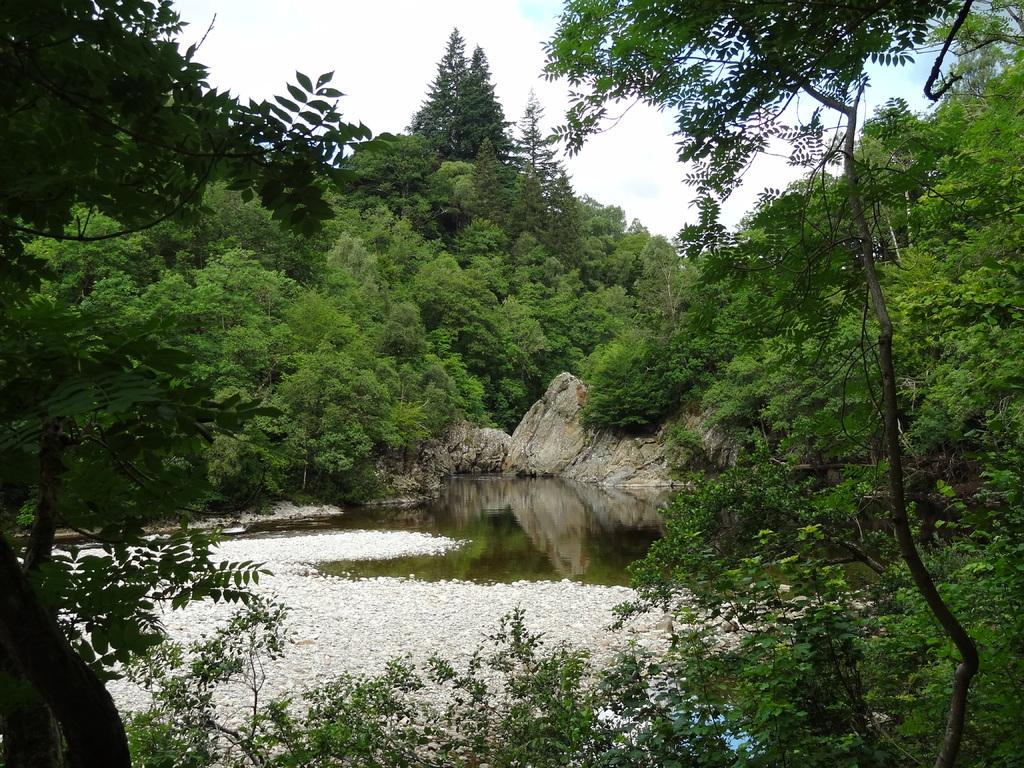What is the primary element visible in the image? There is water in the image. What other objects can be seen in the image? There are rocks in the image. What can be seen in the background of the image? There are trees and the sky visible in the background of the image. What type of jeans is the rock wearing in the image? There are no jeans or rocks wearing clothing in the image. The rocks are natural objects, and jeans are a type of clothing worn by humans, not rocks. 